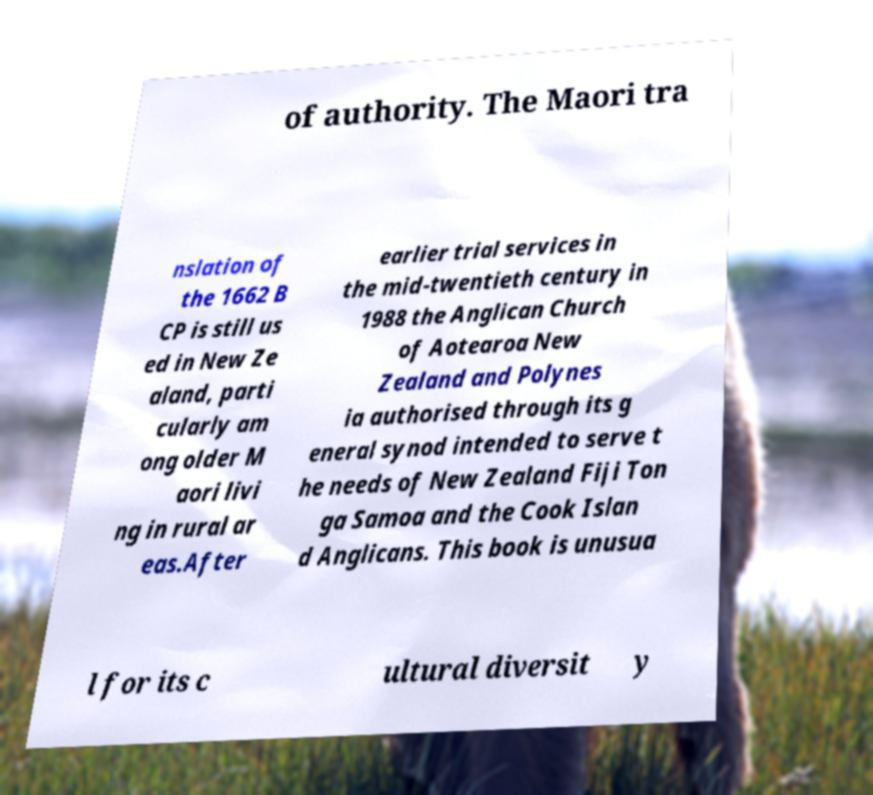Could you assist in decoding the text presented in this image and type it out clearly? of authority. The Maori tra nslation of the 1662 B CP is still us ed in New Ze aland, parti cularly am ong older M aori livi ng in rural ar eas.After earlier trial services in the mid-twentieth century in 1988 the Anglican Church of Aotearoa New Zealand and Polynes ia authorised through its g eneral synod intended to serve t he needs of New Zealand Fiji Ton ga Samoa and the Cook Islan d Anglicans. This book is unusua l for its c ultural diversit y 